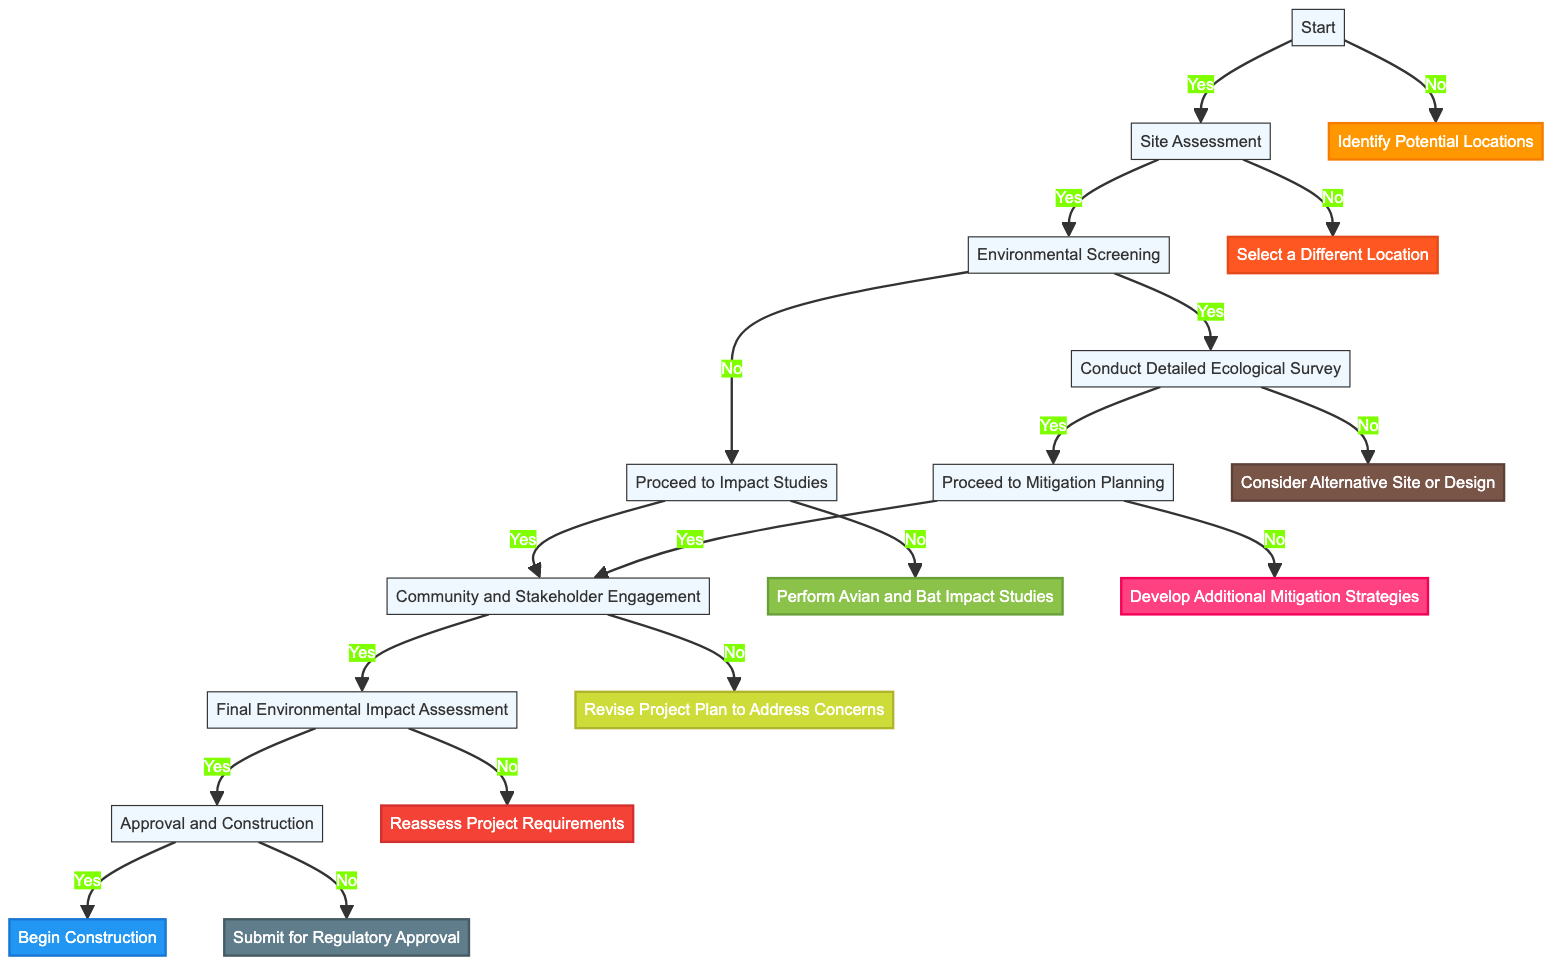Is the first step in the workflow "Start"? The diagram indicates that the very first node labeled "Start" is where the workflow commences, confirming that "Start" is indeed the first step.
Answer: Yes What happens if the site does not meet wind speed requirements? Following the "Site Assessment" node, if the answer to whether the site meets wind speed requirements is "No," the next step indicated is to "Select a Different Location."
Answer: Select a Different Location How many nodes are there in total? By counting all unique sections in the flowchart diagram, which includes nodes like "Start," "Site Assessment," and others, a total of 15 nodes are identified.
Answer: 15 Which step follows "Conduct Detailed Ecological Survey" if operation can coexist with protected species? According to the diagram, if the answer to whether turbine operation can coexist with protected species/habitats is "Yes," then the next step is "Proceed to Mitigation Planning."
Answer: Proceed to Mitigation Planning Are community and stakeholder concerns addressed before the final environmental impact assessment? The diagram specifies that "Community and Stakeholder Engagement" must occur before reaching the "Final Environmental Impact Assessment," making it essential to address concerns first.
Answer: Yes What is the outcome if the overall environmental impact is not acceptable? The diagram shows that if the answer to whether the overall environmental impact is acceptable is "No," the next action to be taken is to "Reassess Project Requirements."
Answer: Reassess Project Requirements What decision comes after "Perform Avian and Bat Impact Studies"? Following the "Perform Avian and Bat Impact Studies" node, the workflow leads to "Community and Stakeholder Engagement," indicating that this step comes next.
Answer: Community and Stakeholder Engagement What do you do if adequate mitigation measures are not in place? The diagram reveals that if adequate mitigation measures are found to be lacking, the following step is to "Develop Additional Mitigation Strategies."
Answer: Develop Additional Mitigation Strategies 